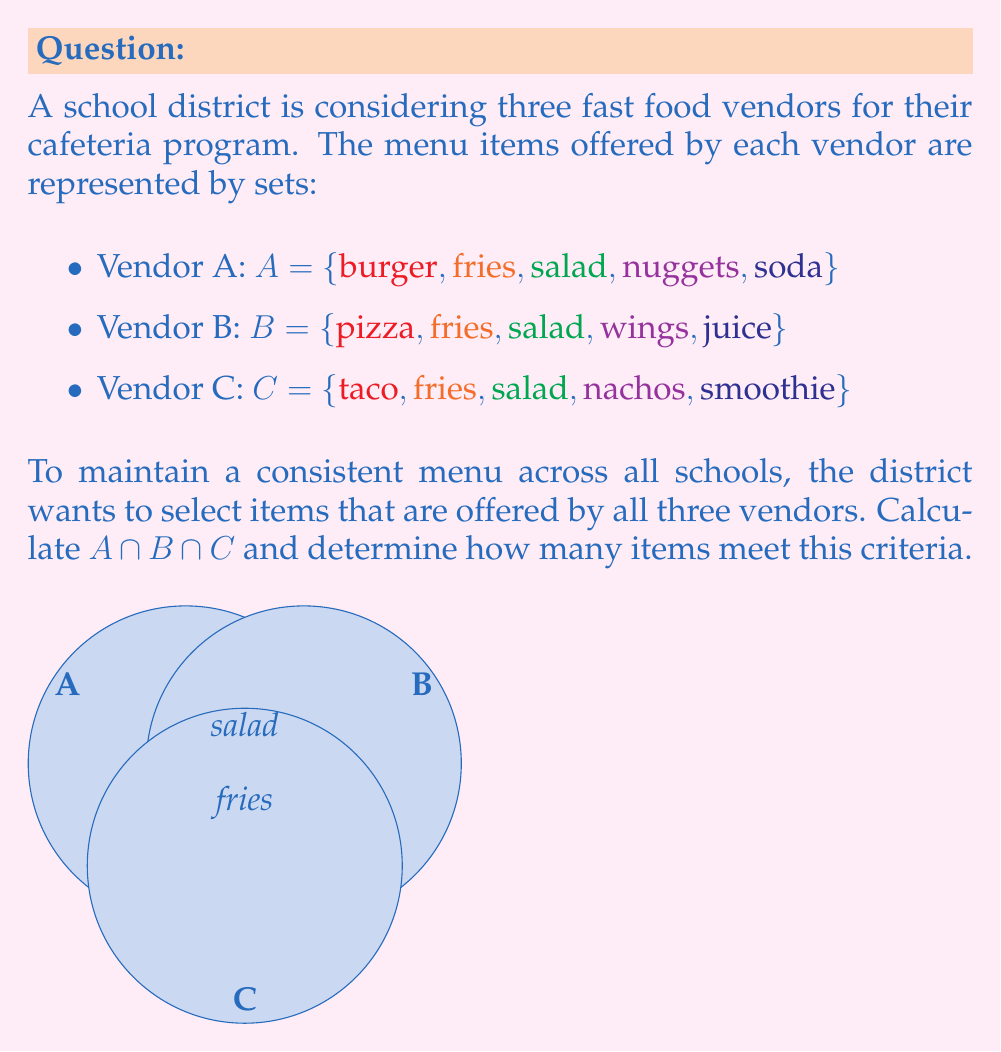Help me with this question. To solve this problem, we need to find the intersection of all three sets. Let's approach this step-by-step:

1) First, let's identify the elements in each set:
   $A = \{burger, fries, salad, nuggets, soda\}$
   $B = \{pizza, fries, salad, wings, juice\}$
   $C = \{taco, fries, salad, nachos, smoothie\}$

2) The intersection $A \cap B \cap C$ will contain only the elements that appear in all three sets.

3) By inspection, we can see that:
   - "fries" appears in all three sets
   - "salad" appears in all three sets
   - No other item appears in all three sets

4) Therefore, the intersection of the three sets is:
   $A \cap B \cap C = \{fries, salad\}$

5) To determine how many items meet the criteria, we simply count the elements in the intersection:
   $|A \cap B \cap C| = 2$

The Venn diagram in the question visually represents this intersection, showing "fries" and "salad" in the center where all three circles overlap.
Answer: $A \cap B \cap C = \{fries, salad\}$; 2 items 